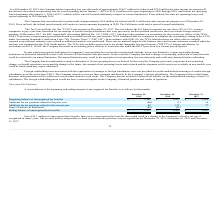From Quicklogic Corporation's financial document, What are the respective beginning balance of unrecognized tax benefits in 2018 and 2019? The document shows two values: $2,107 and $2,161 (in thousands). From the document: "ng balance of unrecognized tax benefits $ 2,161 $ 2,107 $ 2,014 Beginning balance of unrecognized tax benefits $ 2,161 $ 2,107 $ 2,014..." Also, What are the respective additions for tax positions related to the prior year in 2018 and 2019? The document shows two values: (2) and (46) (in thousands). From the document: "itions for tax positions related to the prior year (46) (2 ) 16..." Also, What are the respective additions for tax positions related to the current year in 2018 and 2019? The document shows two values: 125 and 88 (in thousands). From the document: "ons for tax positions related to the current year 88 125 77 for tax positions related to the current year 88 125 77..." Also, can you calculate: What is the average beginning balance of unrecognized tax benefits in 2018 and 2019? To answer this question, I need to perform calculations using the financial data. The calculation is: ($2,107 + $2,161)/2 , which equals 2134 (in thousands). This is based on the information: "Beginning balance of unrecognized tax benefits $ 2,161 $ 2,107 $ 2,014 ng balance of unrecognized tax benefits $ 2,161 $ 2,107 $ 2,014..." The key data points involved are: 2,107, 2,161. Also, can you calculate: What is the average additions for tax positions related to the prior year in 2018 and 2019? To answer this question, I need to perform calculations using the financial data. The calculation is: -(2 + 46)/2 , which equals -24 (in thousands). This is based on the information: "for tax positions related to the prior year (46) (2 ) 16 ions for tax positions related to the prior year (46) (2 ) 16..." The key data points involved are: 46. Also, can you calculate: What is the average additions for tax positions related to the current year in 2018 and 2019? To answer this question, I need to perform calculations using the financial data. The calculation is: (125 + 88)/2 , which equals 106.5 (in thousands). This is based on the information: "ons for tax positions related to the current year 88 125 77 for tax positions related to the current year 88 125 77..." The key data points involved are: 125, 88. 